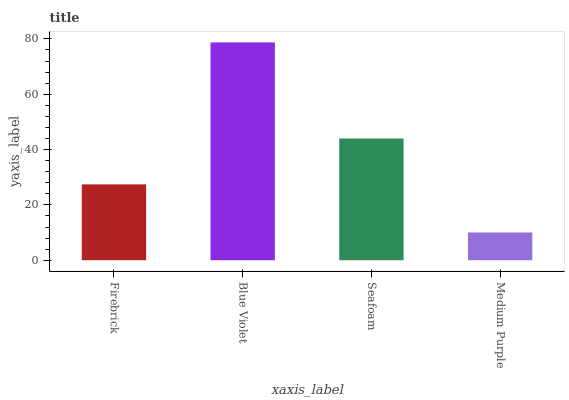Is Medium Purple the minimum?
Answer yes or no. Yes. Is Blue Violet the maximum?
Answer yes or no. Yes. Is Seafoam the minimum?
Answer yes or no. No. Is Seafoam the maximum?
Answer yes or no. No. Is Blue Violet greater than Seafoam?
Answer yes or no. Yes. Is Seafoam less than Blue Violet?
Answer yes or no. Yes. Is Seafoam greater than Blue Violet?
Answer yes or no. No. Is Blue Violet less than Seafoam?
Answer yes or no. No. Is Seafoam the high median?
Answer yes or no. Yes. Is Firebrick the low median?
Answer yes or no. Yes. Is Firebrick the high median?
Answer yes or no. No. Is Seafoam the low median?
Answer yes or no. No. 